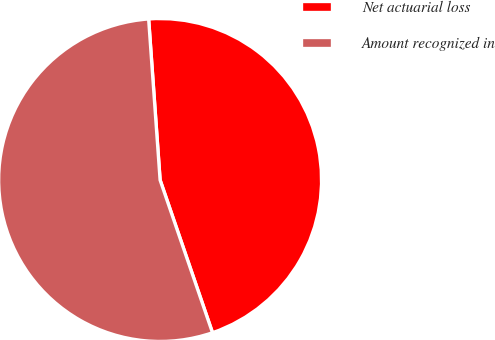Convert chart. <chart><loc_0><loc_0><loc_500><loc_500><pie_chart><fcel>Net actuarial loss<fcel>Amount recognized in<nl><fcel>45.87%<fcel>54.13%<nl></chart> 